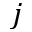Convert formula to latex. <formula><loc_0><loc_0><loc_500><loc_500>j</formula> 